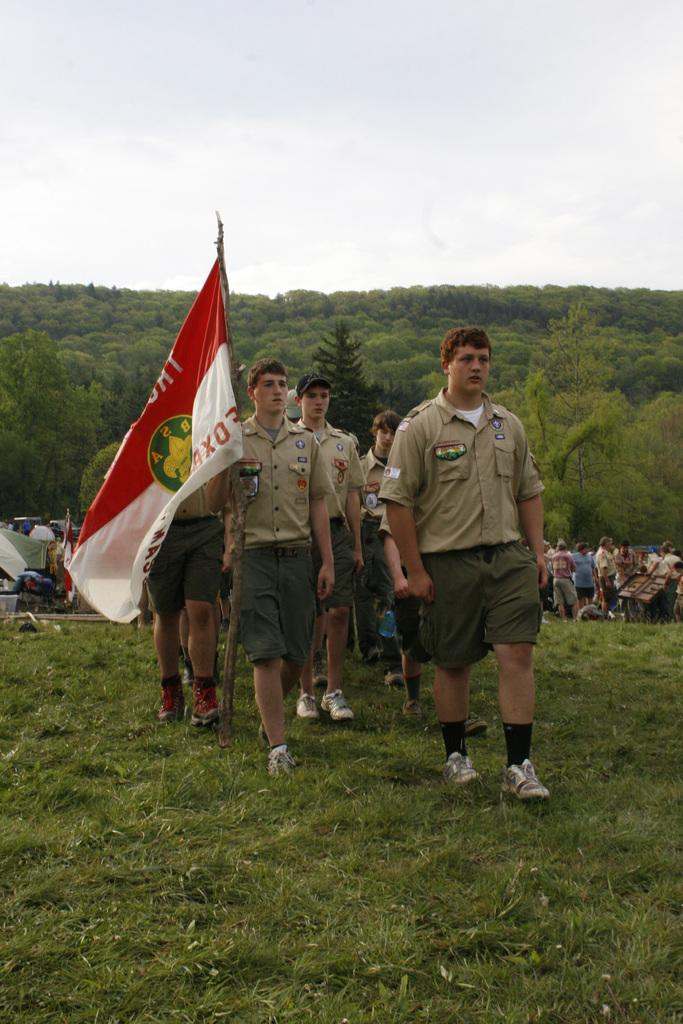What is the main subject of the image? The main subject of the image is the boys in the center. What is the boy holding in the image? One boy is holding a flag in the image. What type of terrain is visible at the bottom of the image? There is grass at the bottom of the image. What can be seen in the background of the image? There are people, trees, and the sky visible in the background of the image. What type of mark can be seen on the boy's forehead in the image? There is no mark visible on the boy's forehead in the image. What decision did the boys make before the image was taken? The image does not provide any information about a decision made by the boys before it was taken. 